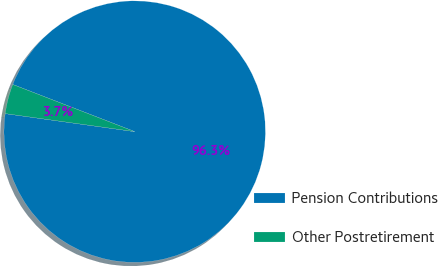<chart> <loc_0><loc_0><loc_500><loc_500><pie_chart><fcel>Pension Contributions<fcel>Other Postretirement<nl><fcel>96.33%<fcel>3.67%<nl></chart> 